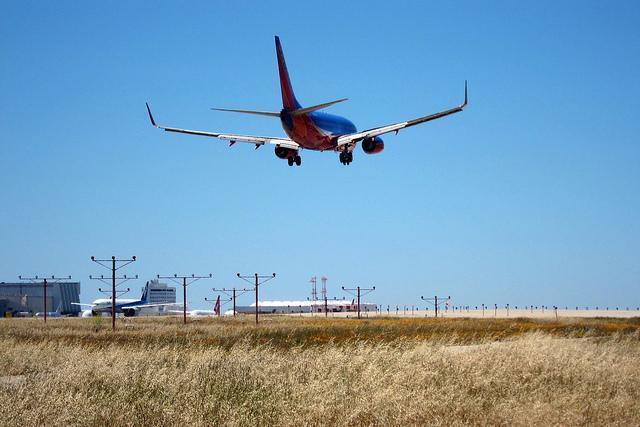How many planes pictured?
Give a very brief answer. 2. 